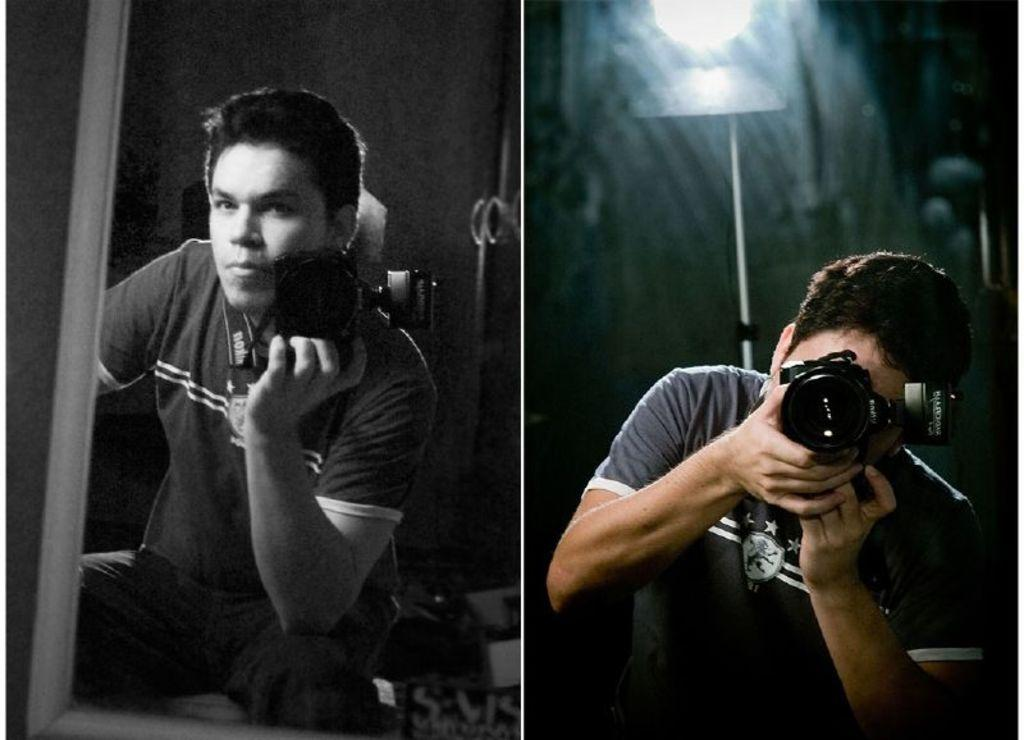What is the main subject of the image? There is a photo of a person in the image. What is the person in the image doing? The person is taking a picture on the camera in the image. Can you describe the lighting in the image? There is light visible in the right side corner of the image. Can you tell me how many hens are visible in the image? There are no hens present in the image. What type of eggs can be seen in the image? There are no eggs present in the image. 